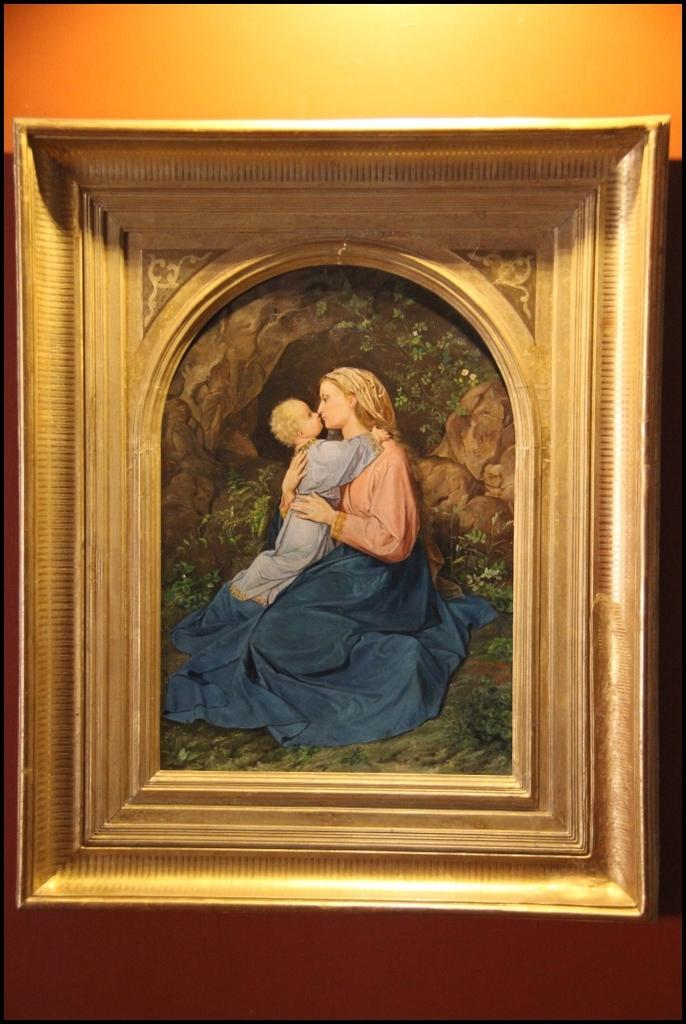What is hanging on the wall in the foreground of the image? There is a frame on the wall in the foreground of the foreground of the image. What is depicted in the frame? The frame contains a painting of a woman and a baby. What can be seen in the background of the image? There are rocks and greenery visible in the background of the image. What type of pen is the baby holding in the painting? There is no pen present in the painting; it depicts a woman and a baby without any writing instruments. 